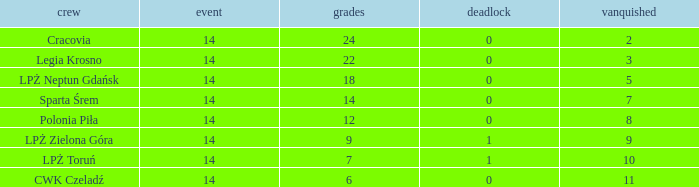What is the highest loss with points less than 7? 11.0. 